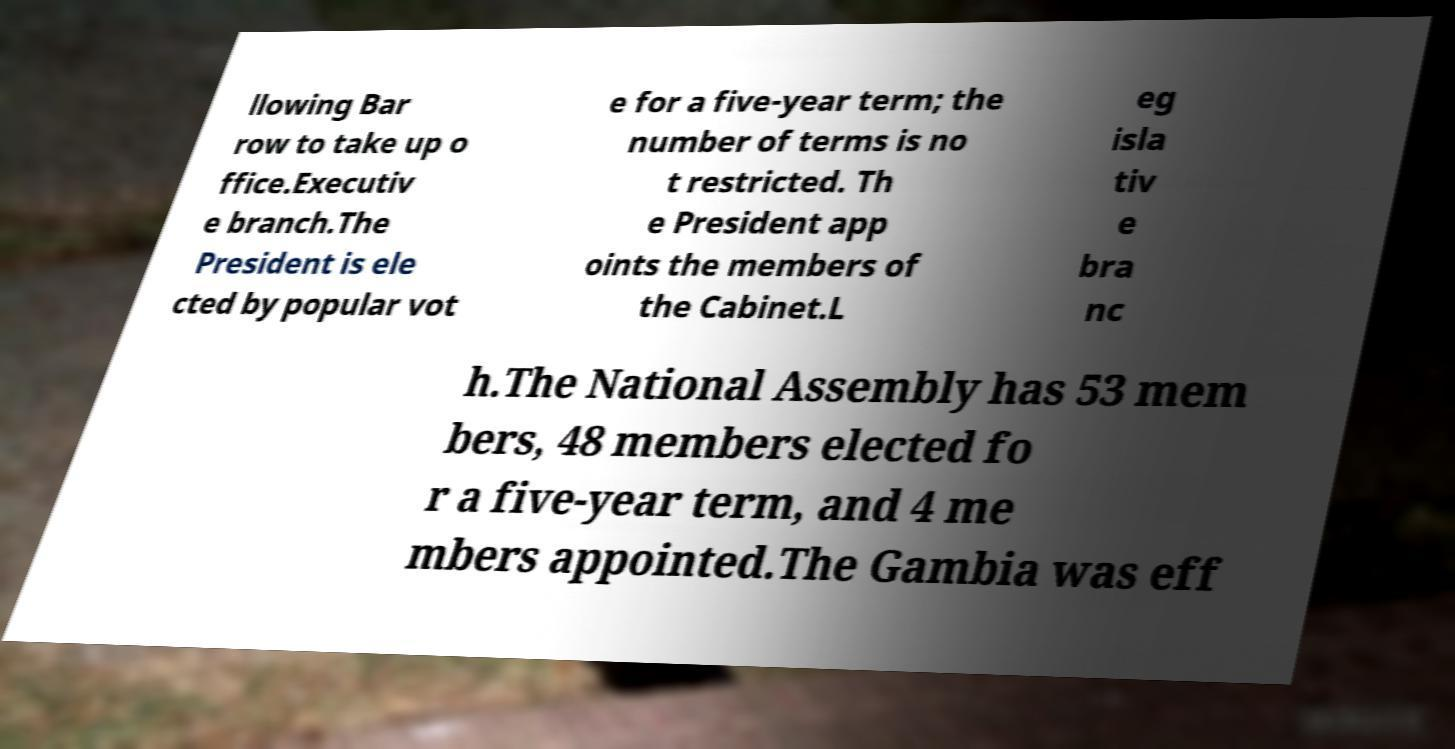I need the written content from this picture converted into text. Can you do that? llowing Bar row to take up o ffice.Executiv e branch.The President is ele cted by popular vot e for a five-year term; the number of terms is no t restricted. Th e President app oints the members of the Cabinet.L eg isla tiv e bra nc h.The National Assembly has 53 mem bers, 48 members elected fo r a five-year term, and 4 me mbers appointed.The Gambia was eff 